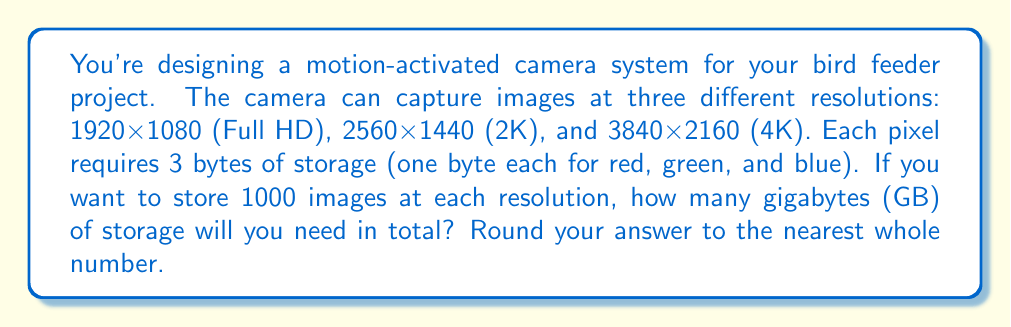Can you solve this math problem? Let's break this down step-by-step:

1) First, we need to calculate the number of pixels for each resolution:
   - Full HD: $1920 \times 1080 = 2,073,600$ pixels
   - 2K: $2560 \times 1440 = 3,686,400$ pixels
   - 4K: $3840 \times 2160 = 8,294,400$ pixels

2) Each pixel requires 3 bytes of storage, so we multiply the number of pixels by 3:
   - Full HD: $2,073,600 \times 3 = 6,220,800$ bytes
   - 2K: $3,686,400 \times 3 = 11,059,200$ bytes
   - 4K: $8,294,400 \times 3 = 24,883,200$ bytes

3) We need to store 1000 images at each resolution, so we multiply each result by 1000:
   - Full HD: $6,220,800 \times 1000 = 6,220,800,000$ bytes
   - 2K: $11,059,200 \times 1000 = 11,059,200,000$ bytes
   - 4K: $24,883,200 \times 1000 = 24,883,200,000$ bytes

4) Now we sum these up:
   $6,220,800,000 + 11,059,200,000 + 24,883,200,000 = 42,163,200,000$ bytes

5) To convert to gigabytes, we divide by $1,073,741,824$ (the number of bytes in a gigabyte):
   $$\frac{42,163,200,000}{1,073,741,824} \approx 39.27 \text{ GB}$$

6) Rounding to the nearest whole number, we get 39 GB.
Answer: 39 GB 